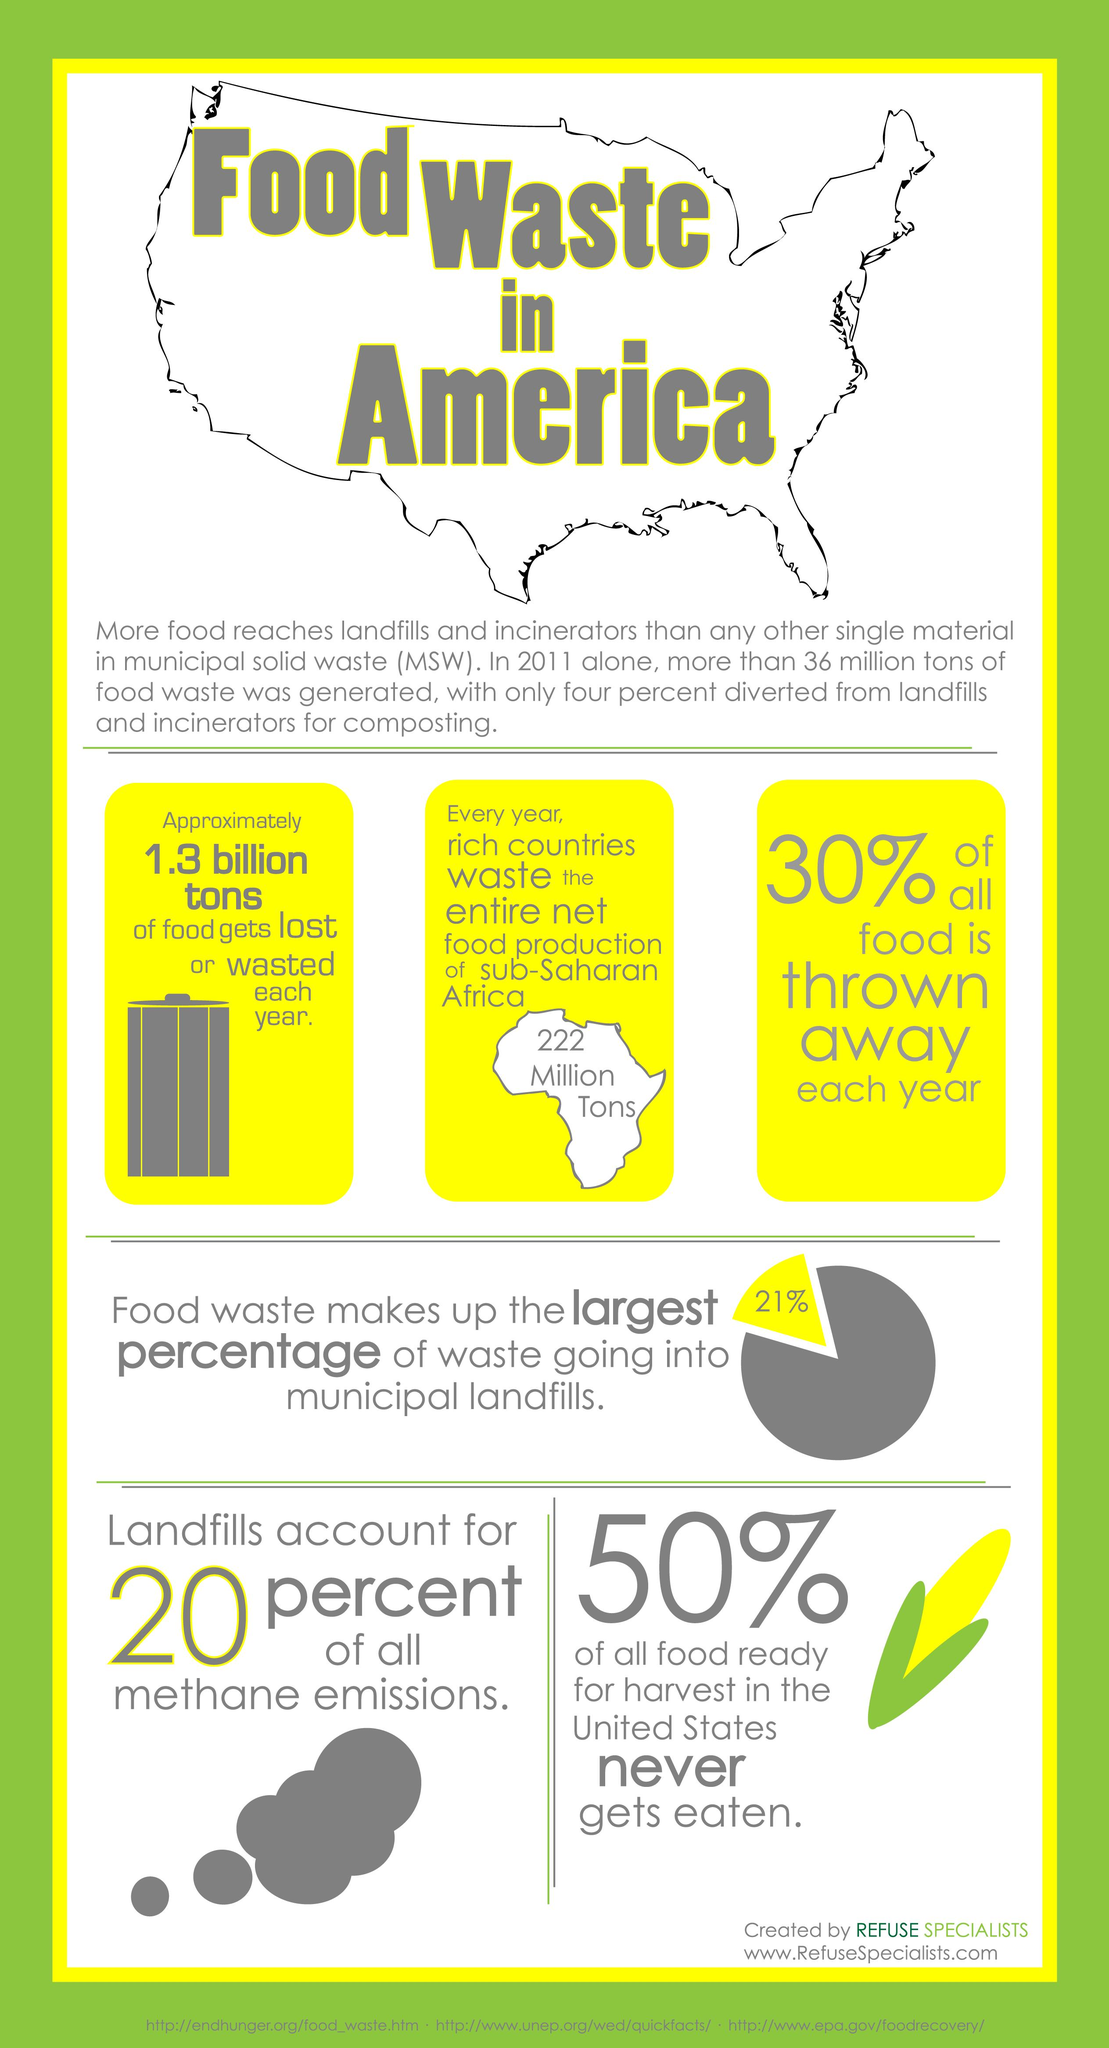Give some essential details in this illustration. According to recent data, approximately 21% of waste sent to municipal landfills is derived from food waste. The net food production in sub-Saharan Africa is approximately 222 million tons. The color of the corn kernel is yellow. According to estimates, approximately 1.3 billion tons of food is lost or wasted each year. Landfills are the primary source of 1/5th of the methane emissions in the world. 